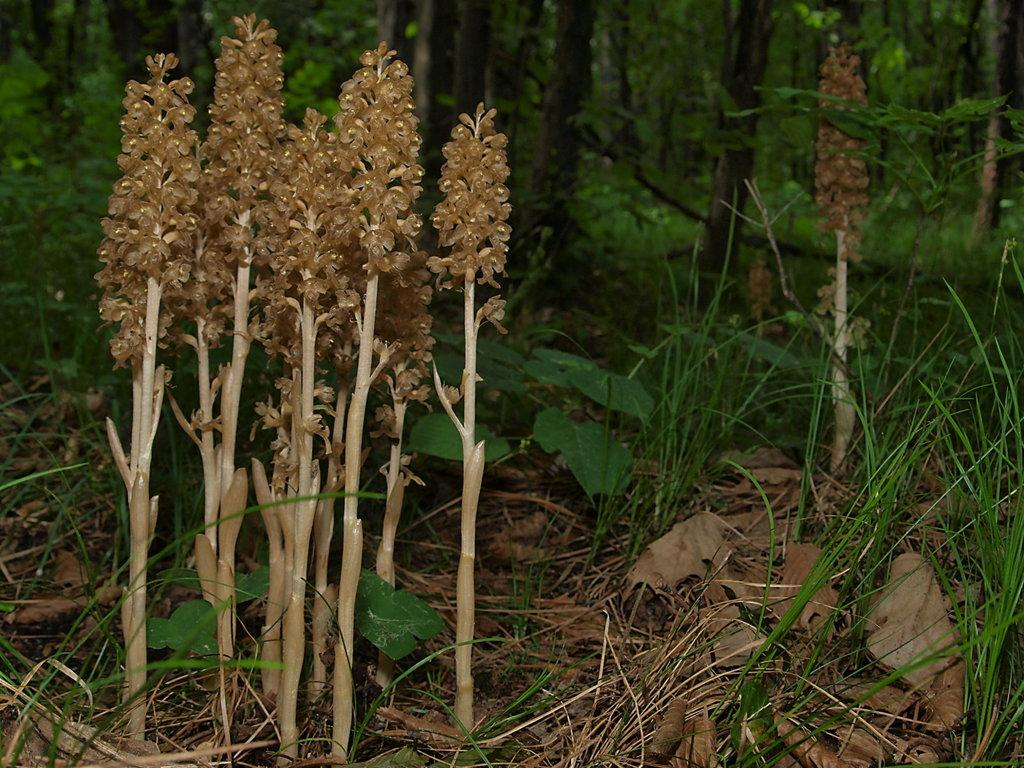What type of plant is in the picture? There is an avis plant in the picture. What can be seen in the background of the picture? There are trees, plants, and grass in the background of the picture. What is present at the bottom of the picture? Dry leaves are present at the bottom of the picture. What type of chicken can be seen in the picture? There is no chicken present in the picture; it features an avis plant, trees, plants, grass, and dry leaves. 